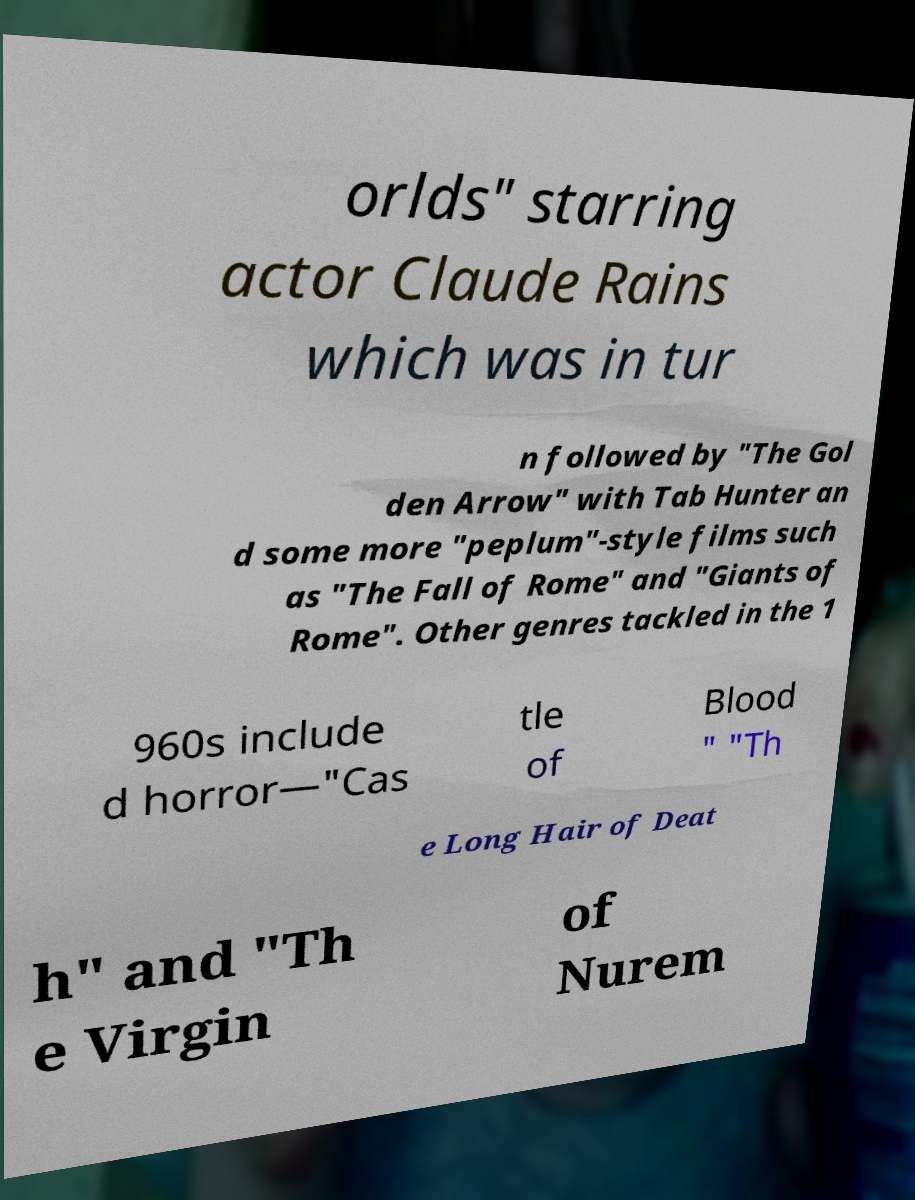Please read and relay the text visible in this image. What does it say? orlds" starring actor Claude Rains which was in tur n followed by "The Gol den Arrow" with Tab Hunter an d some more "peplum"-style films such as "The Fall of Rome" and "Giants of Rome". Other genres tackled in the 1 960s include d horror—"Cas tle of Blood " "Th e Long Hair of Deat h" and "Th e Virgin of Nurem 